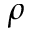Convert formula to latex. <formula><loc_0><loc_0><loc_500><loc_500>\rho</formula> 